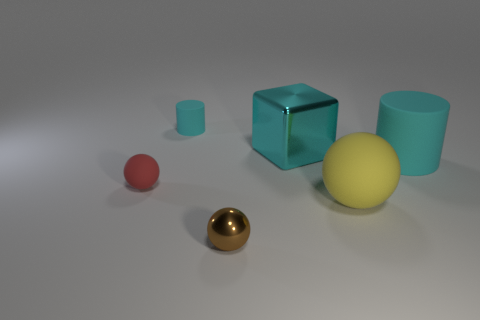The shiny cube that is the same color as the large cylinder is what size?
Offer a very short reply. Large. Are there any other things that have the same size as the red ball?
Your response must be concise. Yes. There is a brown ball; is it the same size as the rubber ball that is in front of the tiny rubber ball?
Your answer should be compact. No. The cyan rubber thing behind the large block has what shape?
Your response must be concise. Cylinder. What color is the large matte object left of the cylinder in front of the tiny cyan rubber cylinder?
Offer a terse response. Yellow. What is the color of the large matte thing that is the same shape as the small cyan thing?
Ensure brevity in your answer.  Cyan. What number of metal objects are the same color as the tiny rubber cylinder?
Provide a short and direct response. 1. There is a small cylinder; is its color the same as the metallic block that is to the right of the tiny cyan cylinder?
Offer a terse response. Yes. There is a matte object that is both behind the large yellow object and right of the brown metal object; what is its shape?
Ensure brevity in your answer.  Cylinder. There is a cyan object to the left of the thing in front of the yellow sphere in front of the small cyan rubber thing; what is it made of?
Provide a succinct answer. Rubber. 